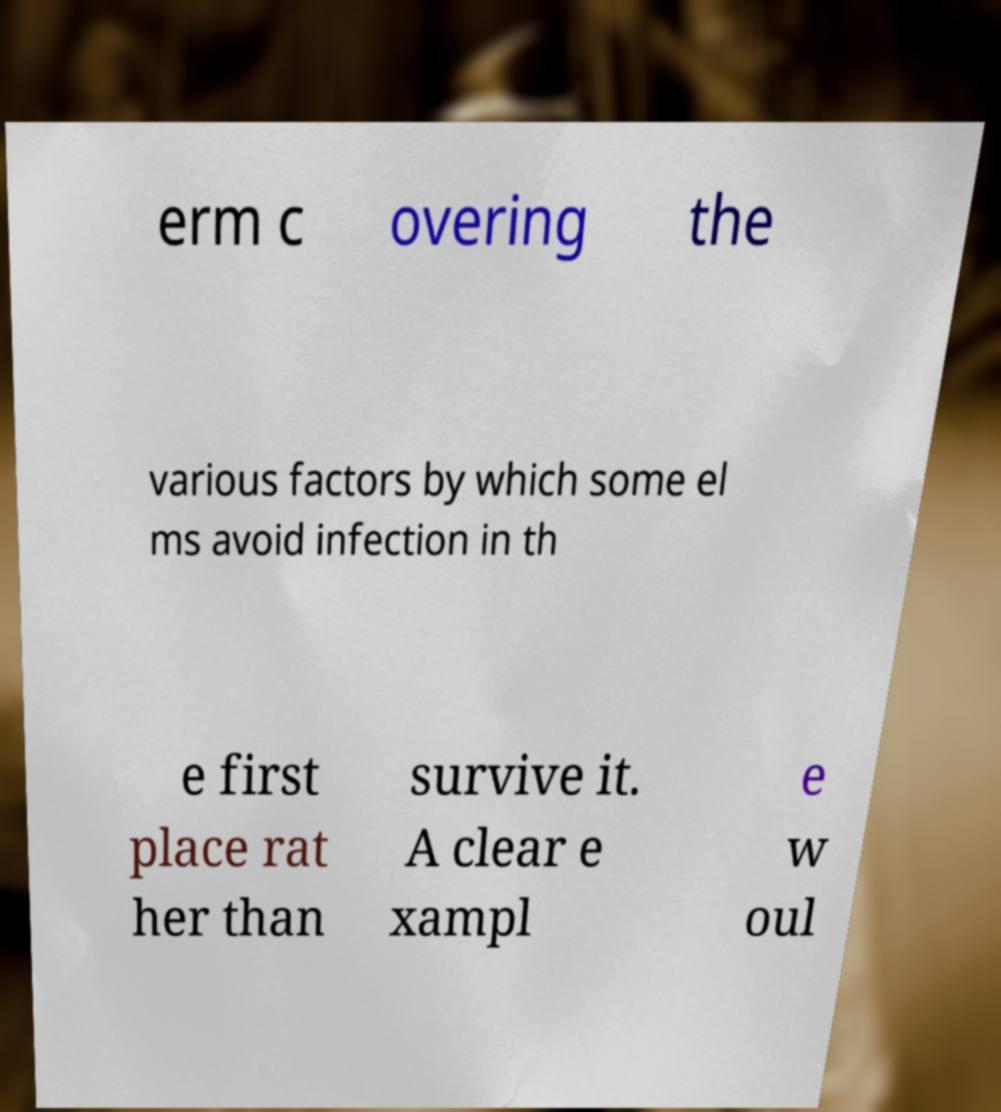For documentation purposes, I need the text within this image transcribed. Could you provide that? erm c overing the various factors by which some el ms avoid infection in th e first place rat her than survive it. A clear e xampl e w oul 